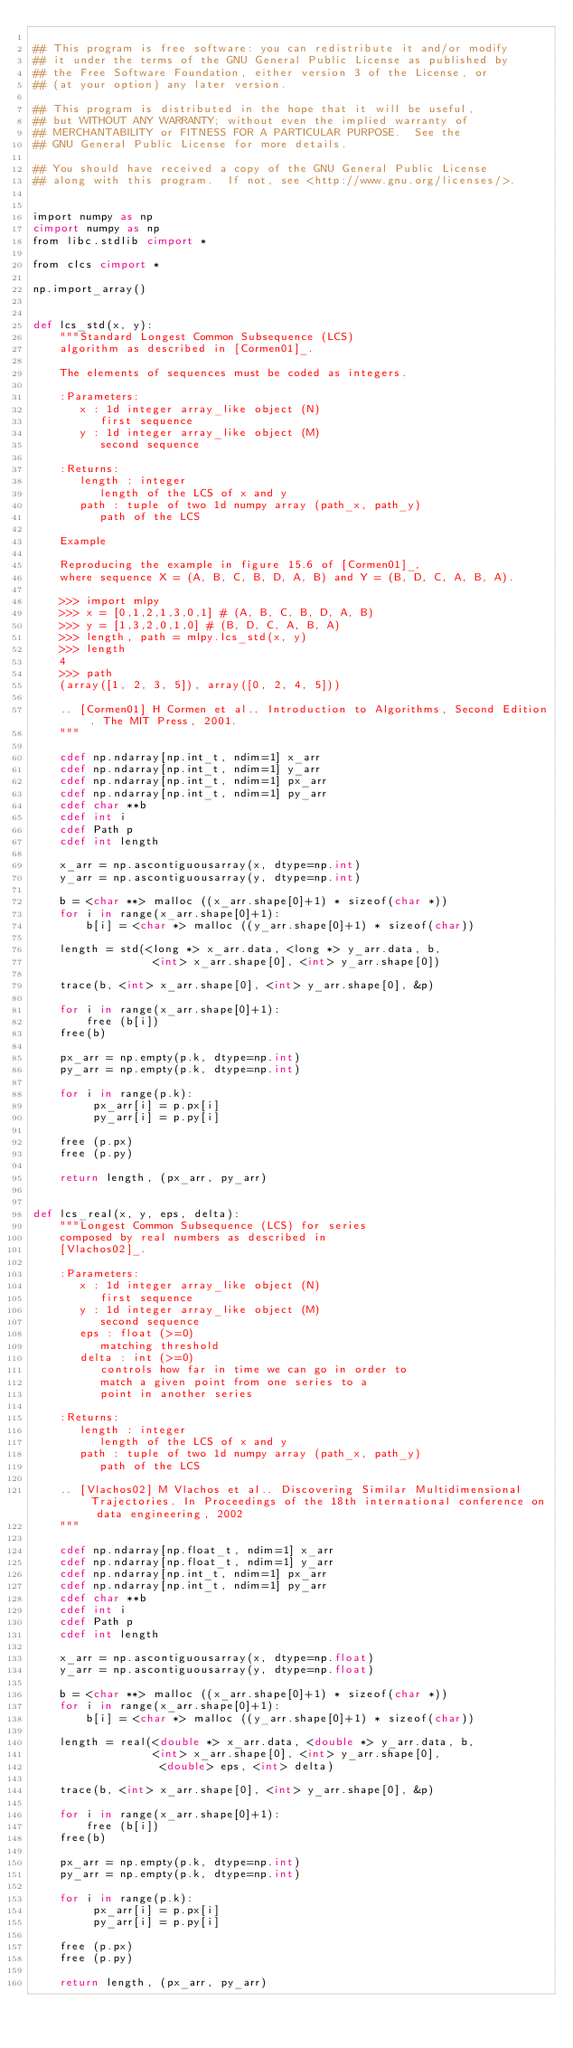Convert code to text. <code><loc_0><loc_0><loc_500><loc_500><_Cython_>
## This program is free software: you can redistribute it and/or modify
## it under the terms of the GNU General Public License as published by
## the Free Software Foundation, either version 3 of the License, or
## (at your option) any later version.

## This program is distributed in the hope that it will be useful,
## but WITHOUT ANY WARRANTY; without even the implied warranty of
## MERCHANTABILITY or FITNESS FOR A PARTICULAR PURPOSE.  See the
## GNU General Public License for more details.

## You should have received a copy of the GNU General Public License
## along with this program.  If not, see <http://www.gnu.org/licenses/>.


import numpy as np
cimport numpy as np
from libc.stdlib cimport *

from clcs cimport *

np.import_array()


def lcs_std(x, y):
    """Standard Longest Common Subsequence (LCS)
    algorithm as described in [Cormen01]_.
    
    The elements of sequences must be coded as integers.
    
    :Parameters:
       x : 1d integer array_like object (N)
          first sequence
       y : 1d integer array_like object (M)
          second sequence

    :Returns:
       length : integer
          length of the LCS of x and y
       path : tuple of two 1d numpy array (path_x, path_y)
          path of the LCS

    Example
    
    Reproducing the example in figure 15.6 of [Cormen01]_,
    where sequence X = (A, B, C, B, D, A, B) and Y = (B, D, C, A, B, A).

    >>> import mlpy
    >>> x = [0,1,2,1,3,0,1] # (A, B, C, B, D, A, B)
    >>> y = [1,3,2,0,1,0] # (B, D, C, A, B, A)
    >>> length, path = mlpy.lcs_std(x, y)
    >>> length
    4
    >>> path
    (array([1, 2, 3, 5]), array([0, 2, 4, 5]))   

    .. [Cormen01] H Cormen et al.. Introduction to Algorithms, Second Edition. The MIT Press, 2001.
    """

    cdef np.ndarray[np.int_t, ndim=1] x_arr
    cdef np.ndarray[np.int_t, ndim=1] y_arr
    cdef np.ndarray[np.int_t, ndim=1] px_arr
    cdef np.ndarray[np.int_t, ndim=1] py_arr
    cdef char **b
    cdef int i
    cdef Path p
    cdef int length

    x_arr = np.ascontiguousarray(x, dtype=np.int)
    y_arr = np.ascontiguousarray(y, dtype=np.int)

    b = <char **> malloc ((x_arr.shape[0]+1) * sizeof(char *))
    for i in range(x_arr.shape[0]+1):
        b[i] = <char *> malloc ((y_arr.shape[0]+1) * sizeof(char))    

    length = std(<long *> x_arr.data, <long *> y_arr.data, b,
                  <int> x_arr.shape[0], <int> y_arr.shape[0])

    trace(b, <int> x_arr.shape[0], <int> y_arr.shape[0], &p)
    
    for i in range(x_arr.shape[0]+1):
        free (b[i])
    free(b)

    px_arr = np.empty(p.k, dtype=np.int)
    py_arr = np.empty(p.k, dtype=np.int)
    
    for i in range(p.k):
         px_arr[i] = p.px[i]
         py_arr[i] = p.py[i]

    free (p.px)
    free (p.py)
    
    return length, (px_arr, py_arr)


def lcs_real(x, y, eps, delta):
    """Longest Common Subsequence (LCS) for series
    composed by real numbers as described in 
    [Vlachos02]_.
       
    :Parameters:
       x : 1d integer array_like object (N)
          first sequence
       y : 1d integer array_like object (M)
          second sequence
       eps : float (>=0)
          matching threshold
       delta : int (>=0)
          controls how far in time we can go in order to
          match a given point from one series to a 
          point in another series

    :Returns:
       length : integer
          length of the LCS of x and y
       path : tuple of two 1d numpy array (path_x, path_y)
          path of the LCS

    .. [Vlachos02] M Vlachos et al.. Discovering Similar Multidimensional Trajectories. In Proceedings of the 18th international conference on data engineering, 2002
    """

    cdef np.ndarray[np.float_t, ndim=1] x_arr
    cdef np.ndarray[np.float_t, ndim=1] y_arr
    cdef np.ndarray[np.int_t, ndim=1] px_arr
    cdef np.ndarray[np.int_t, ndim=1] py_arr
    cdef char **b
    cdef int i
    cdef Path p
    cdef int length

    x_arr = np.ascontiguousarray(x, dtype=np.float)
    y_arr = np.ascontiguousarray(y, dtype=np.float)

    b = <char **> malloc ((x_arr.shape[0]+1) * sizeof(char *))
    for i in range(x_arr.shape[0]+1):
        b[i] = <char *> malloc ((y_arr.shape[0]+1) * sizeof(char))    

    length = real(<double *> x_arr.data, <double *> y_arr.data, b,
                  <int> x_arr.shape[0], <int> y_arr.shape[0],
                   <double> eps, <int> delta)

    trace(b, <int> x_arr.shape[0], <int> y_arr.shape[0], &p)
    
    for i in range(x_arr.shape[0]+1):
        free (b[i])
    free(b)

    px_arr = np.empty(p.k, dtype=np.int)
    py_arr = np.empty(p.k, dtype=np.int)
    
    for i in range(p.k):
         px_arr[i] = p.px[i]
         py_arr[i] = p.py[i]

    free (p.px)
    free (p.py)
    
    return length, (px_arr, py_arr)
</code> 